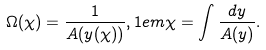<formula> <loc_0><loc_0><loc_500><loc_500>\Omega ( \chi ) = \frac { 1 } { A ( y ( \chi ) ) } , 1 e m \chi = \int \frac { d y } { A ( y ) } .</formula> 